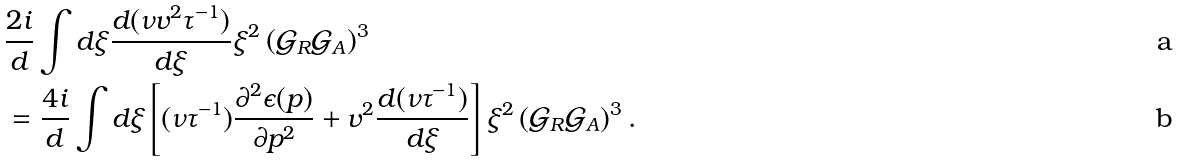<formula> <loc_0><loc_0><loc_500><loc_500>& \frac { 2 i } { d } \int d \xi \frac { d ( \nu v ^ { 2 } \tau ^ { - 1 } ) } { d \xi } \xi ^ { 2 } \left ( { \mathcal { G } } _ { R } { \mathcal { G } } _ { A } \right ) ^ { 3 } \\ & = \frac { 4 i } { d } \int d \xi \left [ ( \nu \tau ^ { - 1 } ) \frac { \partial ^ { 2 } \epsilon ( p ) } { \partial p ^ { 2 } } + v ^ { 2 } \frac { d ( \nu \tau ^ { - 1 } ) } { d \xi } \right ] \xi ^ { 2 } \left ( { \mathcal { G } } _ { R } { \mathcal { G } } _ { A } \right ) ^ { 3 } .</formula> 